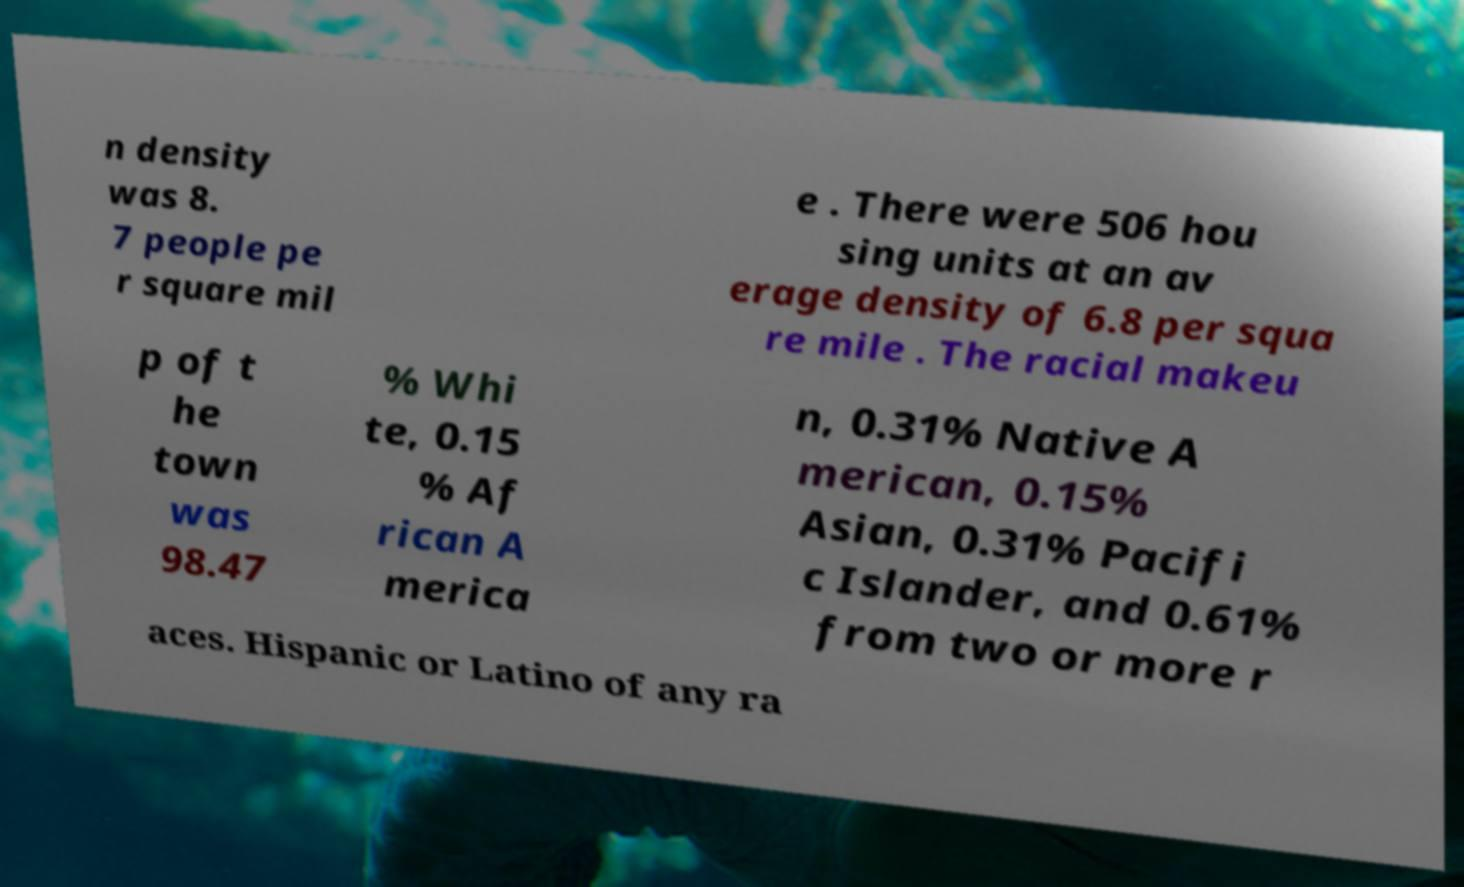Could you extract and type out the text from this image? n density was 8. 7 people pe r square mil e . There were 506 hou sing units at an av erage density of 6.8 per squa re mile . The racial makeu p of t he town was 98.47 % Whi te, 0.15 % Af rican A merica n, 0.31% Native A merican, 0.15% Asian, 0.31% Pacifi c Islander, and 0.61% from two or more r aces. Hispanic or Latino of any ra 